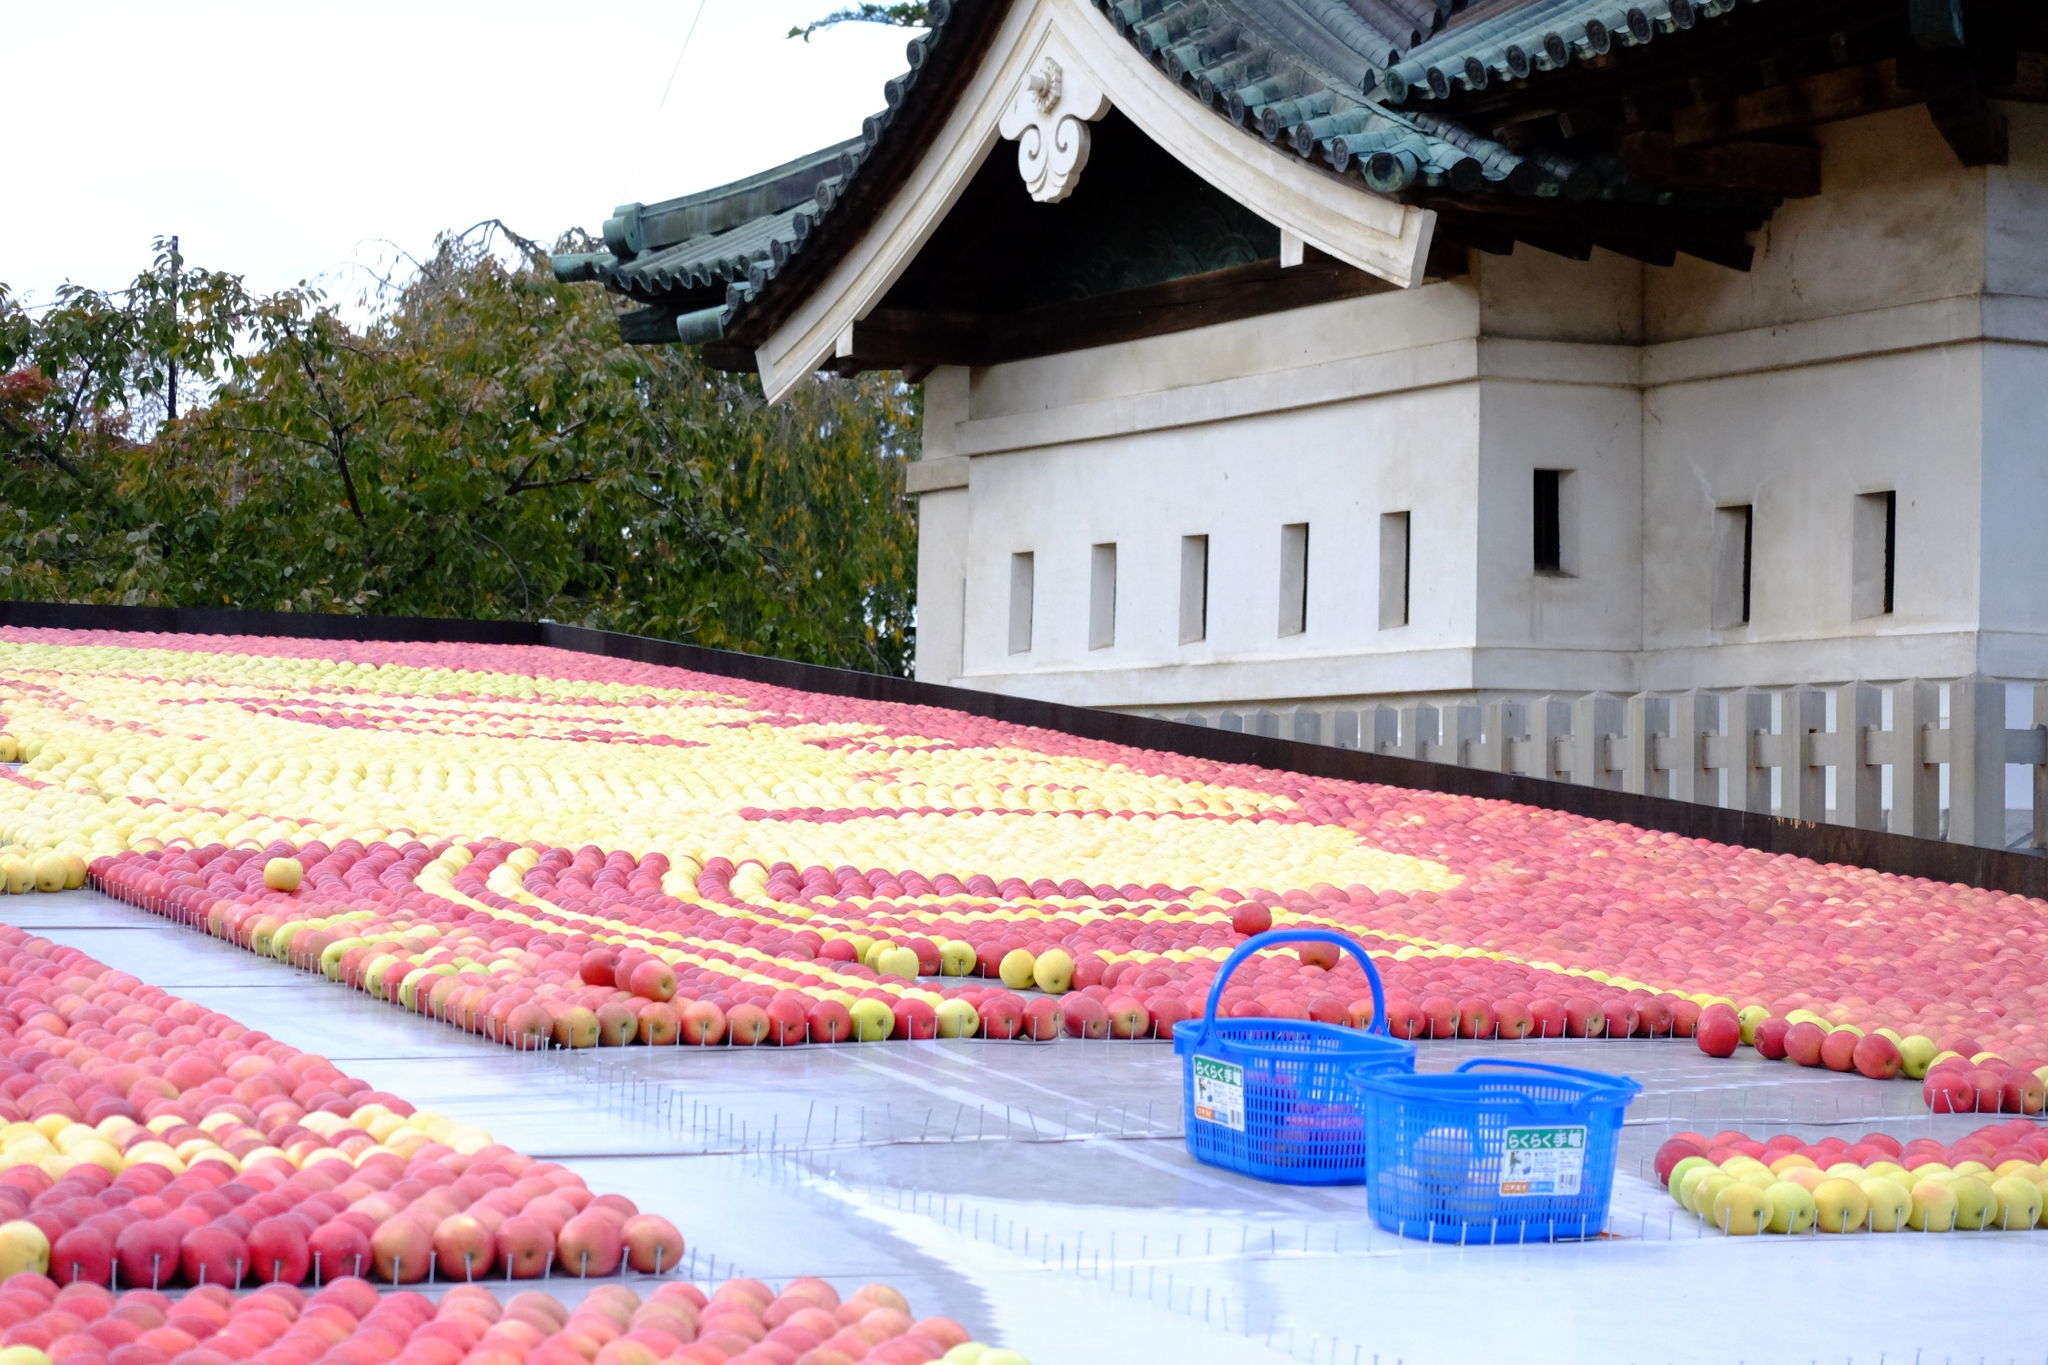What's happening in the scene? The image presents a meticulously arranged display of apples in varying hues of red, yellow, and orange, set against the backdrop of a traditional Japanese temple. The temple, distinguished by its green roof and white walls, adds a touch of architectural beauty to the scene. The foreground features baskets filled with apples, hinting at a possible harvest celebration or local fruit exhibition. This harmonious blend of nature’s bounty and cultural heritage suggests a community event centered around agriculture, with the temple possibly serving a central role in the community's cultural practices. 